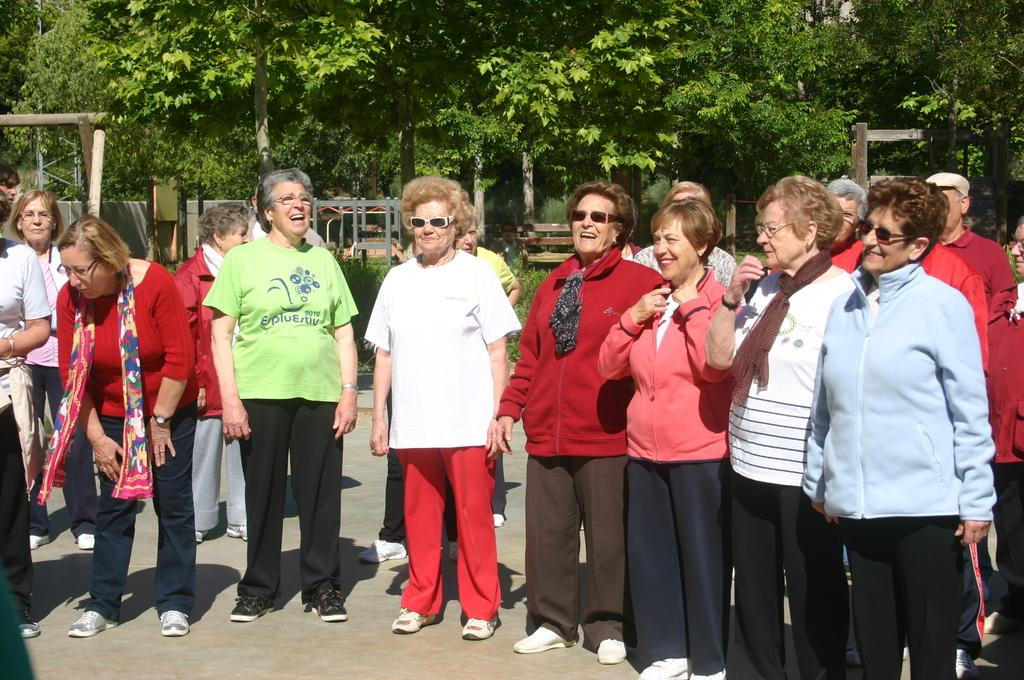What are the people in the image doing? There is a group of people standing on the road in the image. What can be seen in the background of the image? Trees are visible at the top of the image. What object is located in the middle of the image? A bench is present in the middle of the image. How many wishes do the trees grant to the people in the image? There are no wishes granted by the trees in the image, as trees do not have the ability to grant wishes. Are the people in the image brothers? There is no information about the relationship between the people in the image, so we cannot determine if they are brothers. 